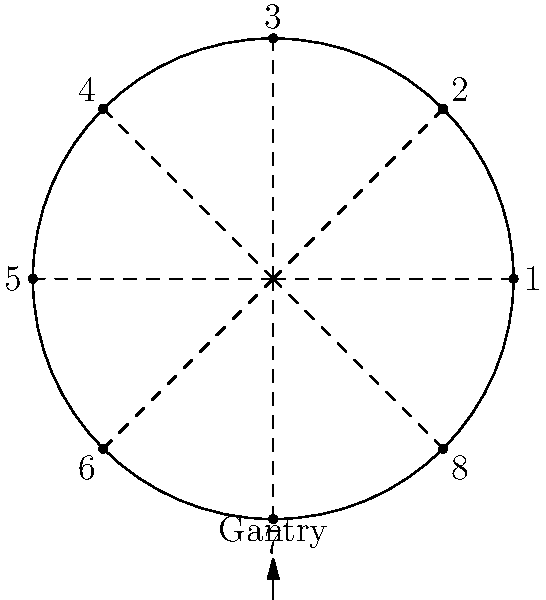Consider the dihedral group $D_8$ representing the symmetries of a CT scanner's gantry with 8 equally spaced positions, as shown in the diagram. If the gantry is currently at position 1 and undergoes a rotation of 135° clockwise followed by a reflection across the vertical axis, what will be its final position? Let's approach this step-by-step:

1) First, we need to understand the elements of $D_8$:
   - Rotations: $r_0$ (identity), $r_1$ (45° CW), $r_2$ (90° CW), ..., $r_7$ (315° CW)
   - Reflections: $s_0$ (across vertical), $s_1$ (across line from 1 to 5), ..., $s_7$ (across line from 8 to 4)

2) The operation described involves two steps:
   a) Rotation of 135° clockwise
   b) Reflection across the vertical axis

3) 135° clockwise rotation:
   - 135° = 3 * 45°, so this is equivalent to $r_3$
   - This moves position 1 to position 4

4) Reflection across the vertical axis:
   - This is the reflection $s_0$
   - It swaps positions across the vertical axis: 4 ↔ 4, 3 ↔ 5, 2 ↔ 6, 1 ↔ 7, 8 ↔ 8

5) Combining these operations:
   - Starting at 1, rotate to 4, then reflect to 4

Therefore, the final position after these operations is 4.

In group theory notation, this can be written as $s_0 \circ r_3(1) = 4$.
Answer: 4 